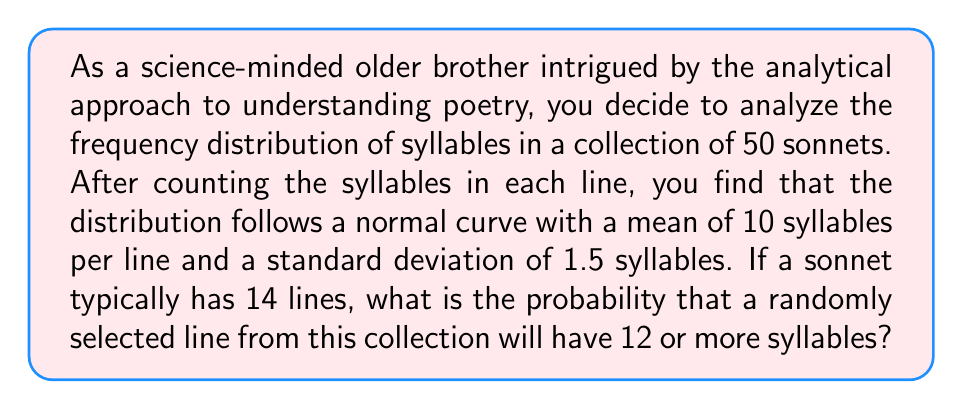Can you answer this question? To solve this problem, we need to use the properties of the normal distribution and the concept of z-scores. Let's break it down step by step:

1. Identify the given information:
   - The distribution is normal
   - Mean (μ) = 10 syllables
   - Standard deviation (σ) = 1.5 syllables
   - We want to find P(X ≥ 12), where X is the number of syllables in a line

2. Calculate the z-score for 12 syllables:
   $$ z = \frac{x - \mu}{\sigma} = \frac{12 - 10}{1.5} = \frac{2}{1.5} \approx 1.33 $$

3. Use the standard normal distribution table or a calculator to find the area to the right of z = 1.33. This represents the probability of a value being greater than or equal to 12.

4. The area to the right of z = 1.33 is approximately 0.0918.

Therefore, the probability of a randomly selected line having 12 or more syllables is about 0.0918 or 9.18%.

This analytical approach allows us to quantify the likelihood of encountering lines with specific syllable counts in the collection of sonnets, providing a mathematical perspective on poetic structure.
Answer: The probability that a randomly selected line from the collection will have 12 or more syllables is approximately 0.0918 or 9.18%. 